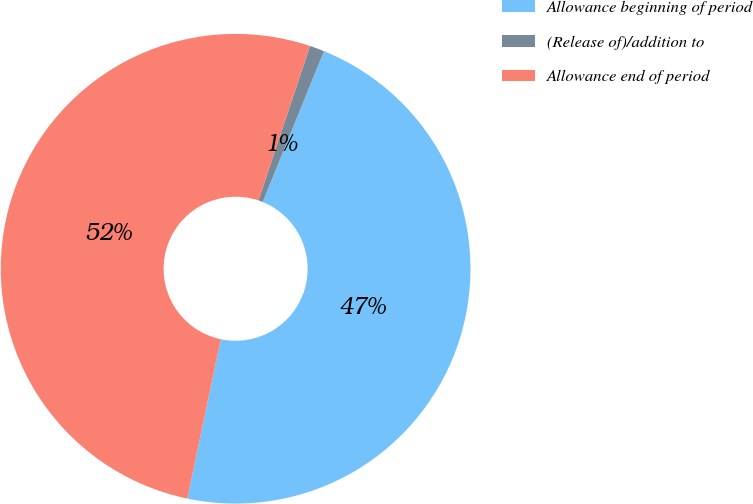Convert chart. <chart><loc_0><loc_0><loc_500><loc_500><pie_chart><fcel>Allowance beginning of period<fcel>(Release of)/addition to<fcel>Allowance end of period<nl><fcel>47.16%<fcel>1.01%<fcel>51.83%<nl></chart> 